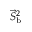<formula> <loc_0><loc_0><loc_500><loc_500>\vec { S } _ { b } ^ { 2 }</formula> 